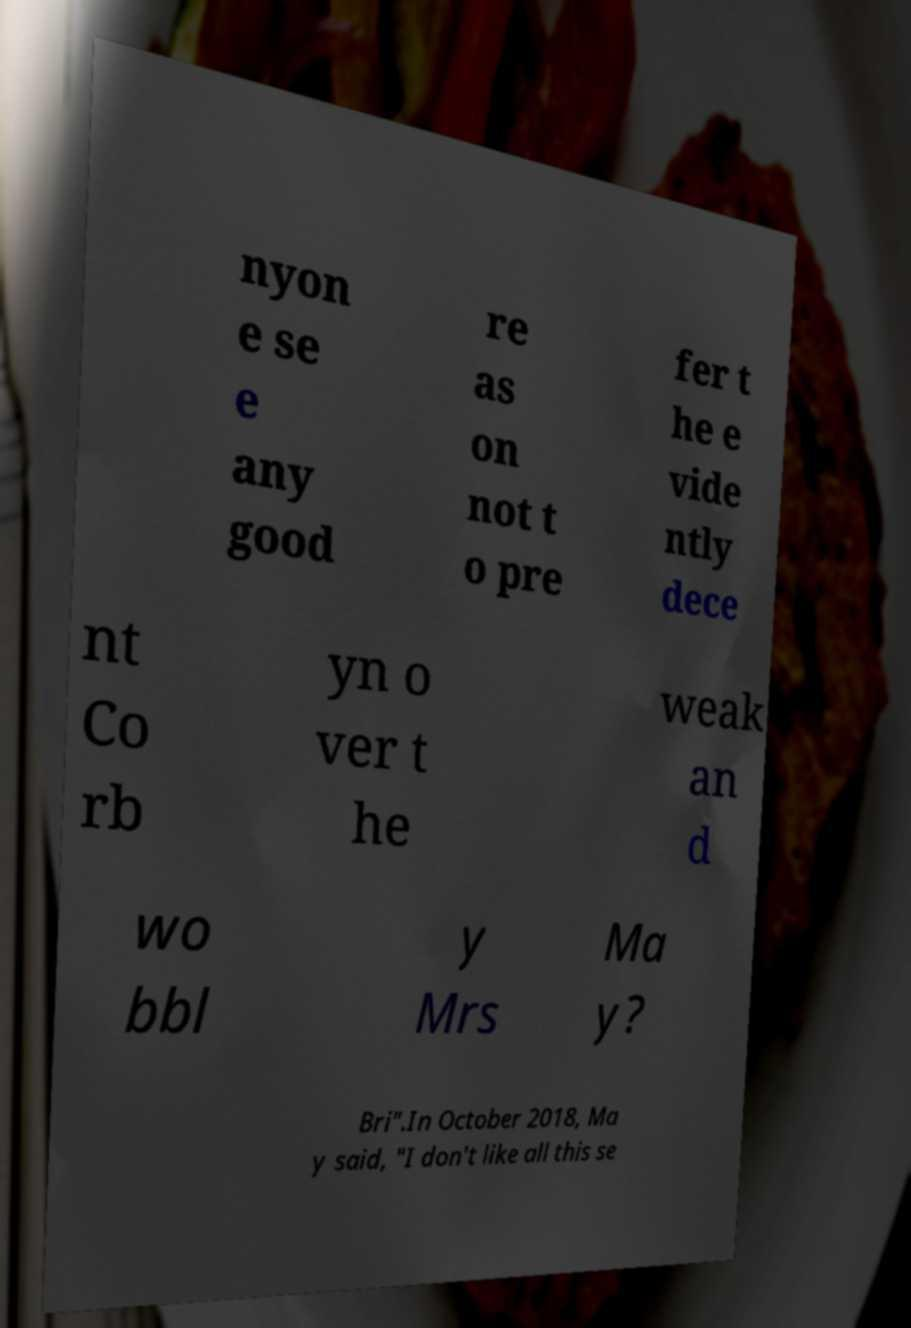For documentation purposes, I need the text within this image transcribed. Could you provide that? nyon e se e any good re as on not t o pre fer t he e vide ntly dece nt Co rb yn o ver t he weak an d wo bbl y Mrs Ma y? Bri".In October 2018, Ma y said, "I don't like all this se 